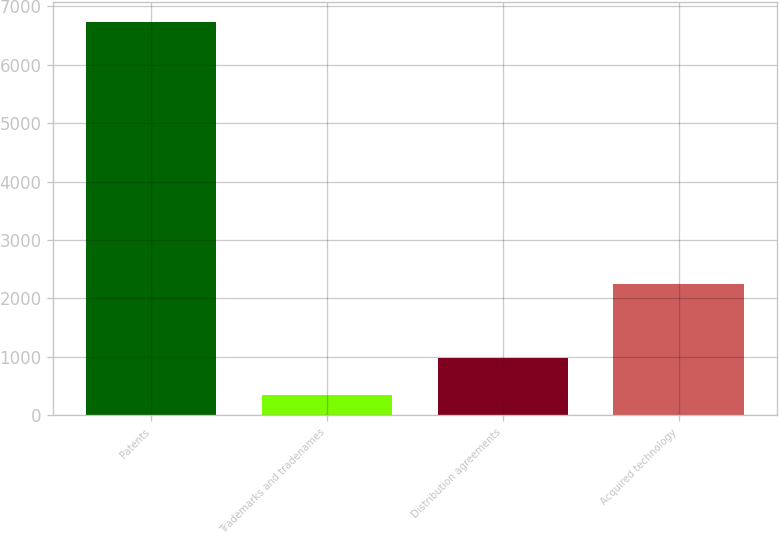Convert chart. <chart><loc_0><loc_0><loc_500><loc_500><bar_chart><fcel>Patents<fcel>Trademarks and tradenames<fcel>Distribution agreements<fcel>Acquired technology<nl><fcel>6734<fcel>343<fcel>982.1<fcel>2255<nl></chart> 